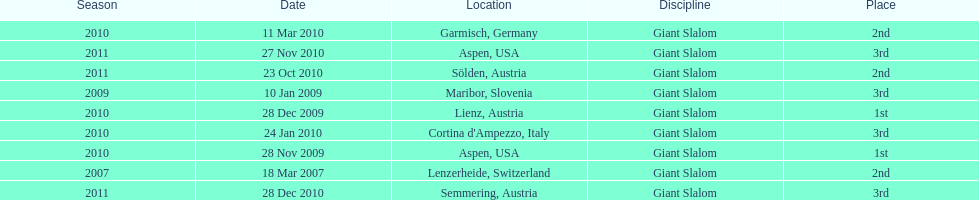The final race finishing place was not 1st but what other place? 3rd. 